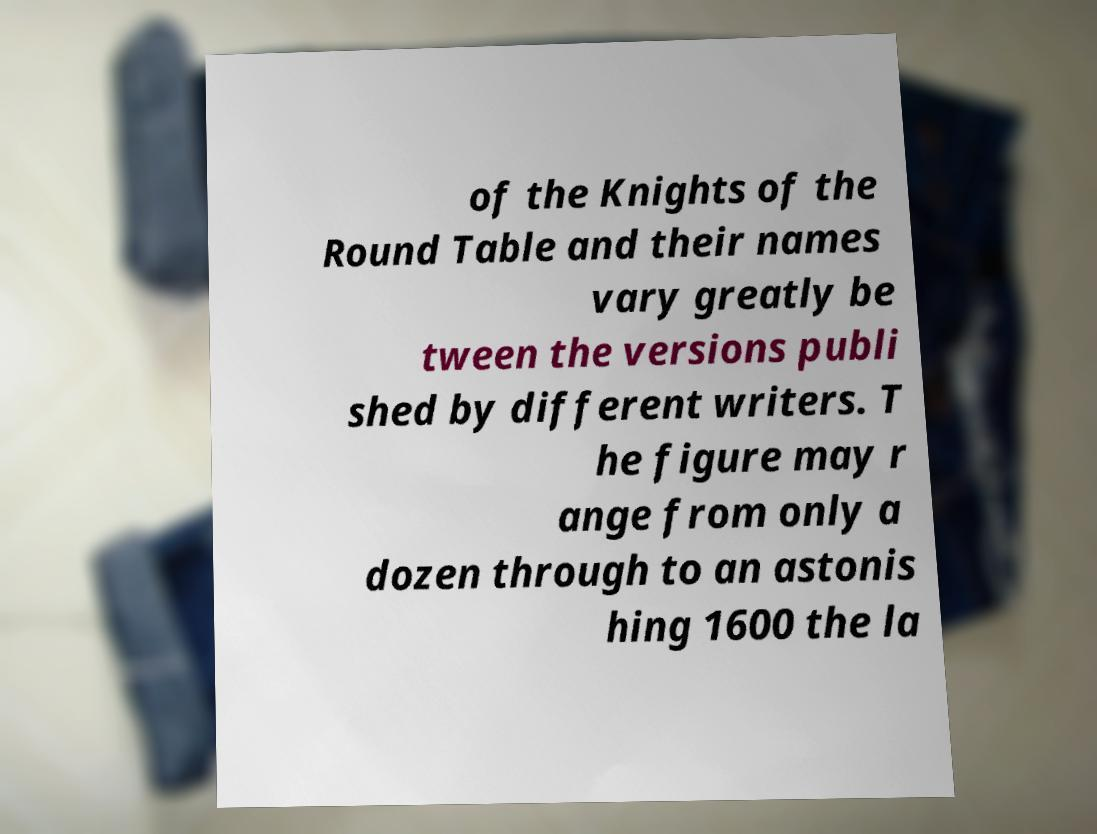Could you assist in decoding the text presented in this image and type it out clearly? of the Knights of the Round Table and their names vary greatly be tween the versions publi shed by different writers. T he figure may r ange from only a dozen through to an astonis hing 1600 the la 